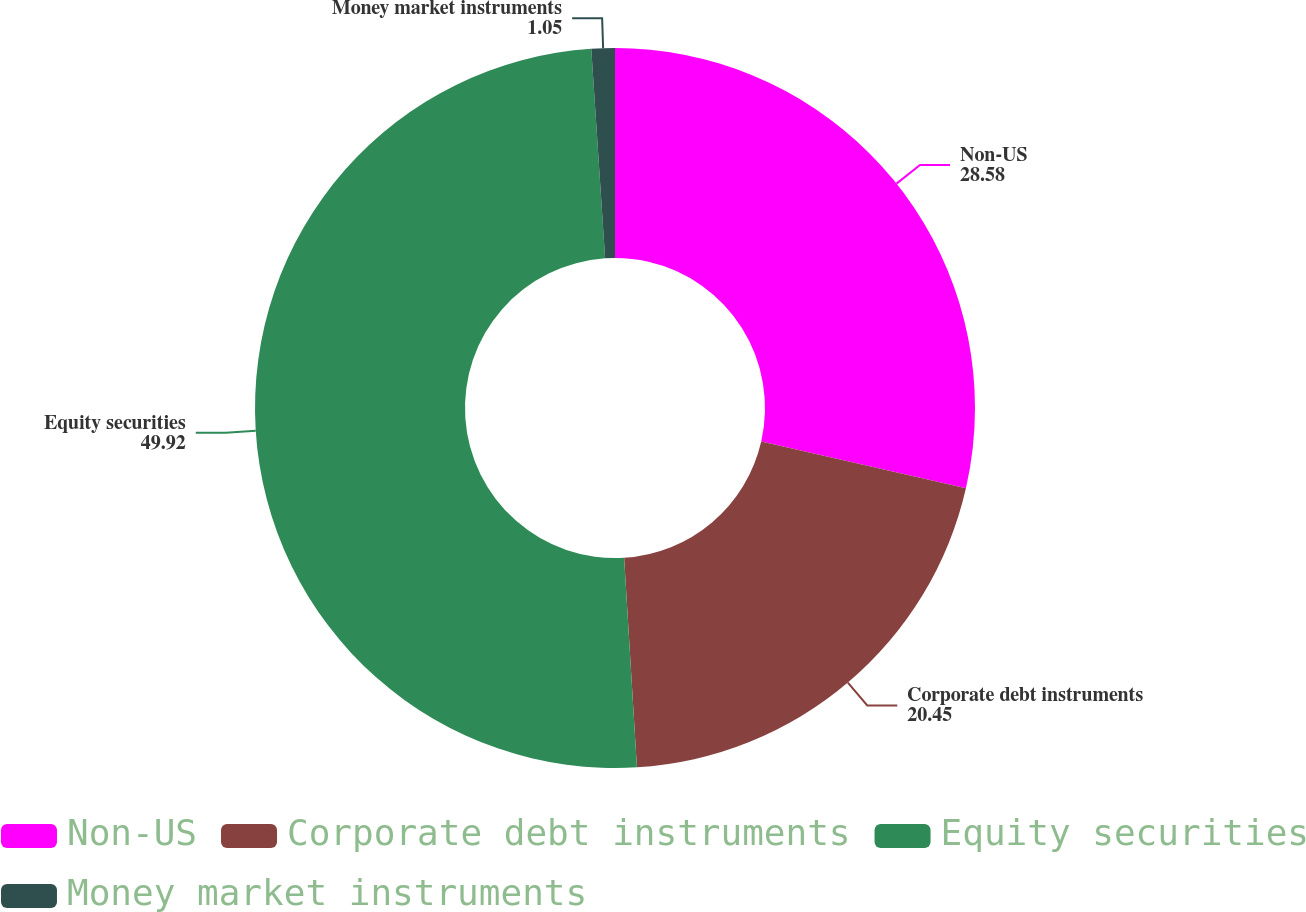<chart> <loc_0><loc_0><loc_500><loc_500><pie_chart><fcel>Non-US<fcel>Corporate debt instruments<fcel>Equity securities<fcel>Money market instruments<nl><fcel>28.58%<fcel>20.45%<fcel>49.92%<fcel>1.05%<nl></chart> 